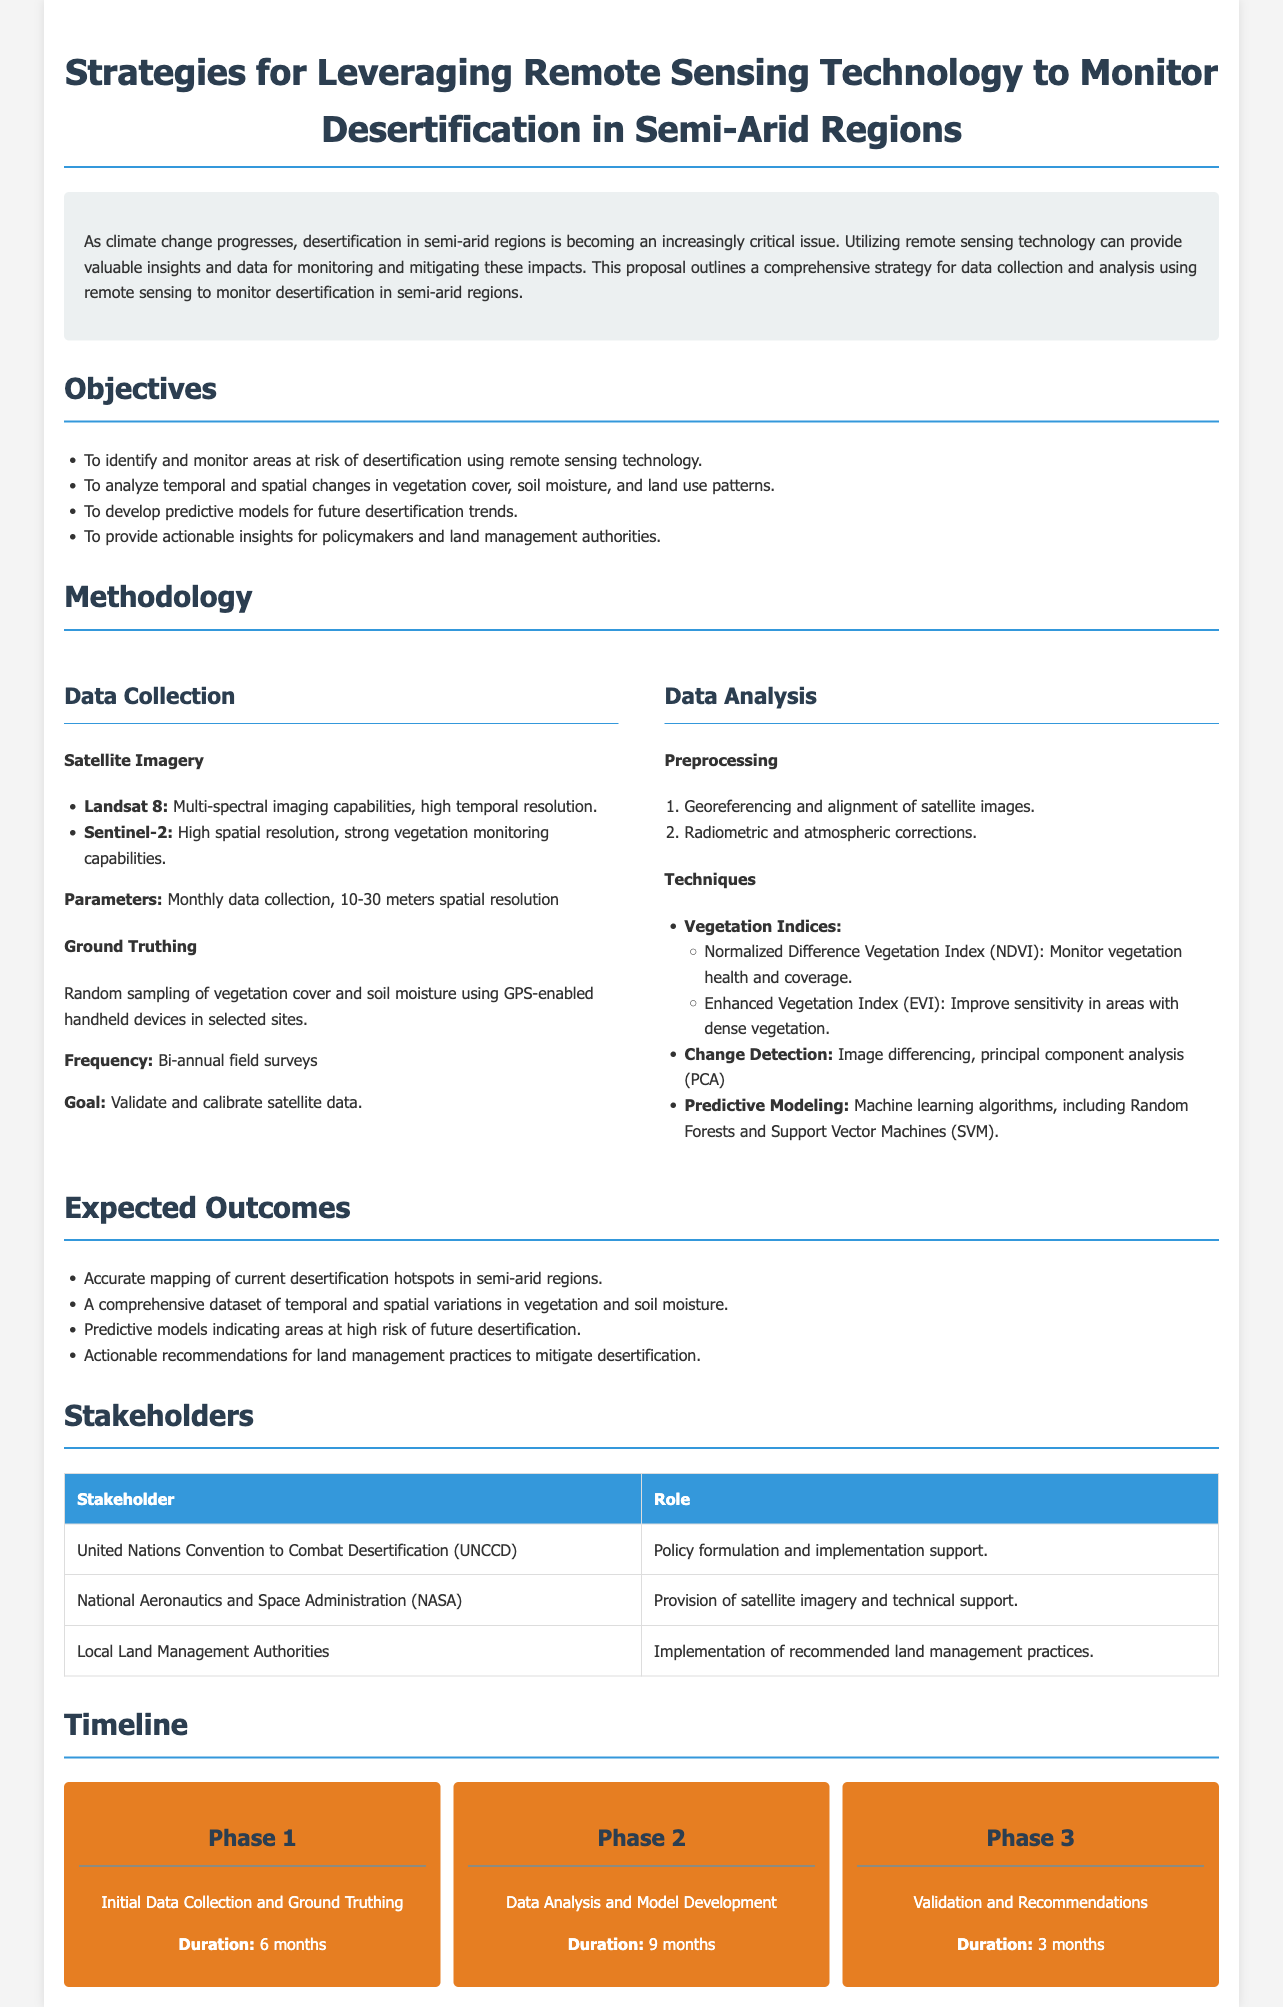What are the main objectives of the proposal? The proposal lists four objectives centered around monitoring desertification in semi-arid regions using remote sensing technology.
Answer: Identify and monitor areas at risk of desertification, analyze temporal and spatial changes, develop predictive models, provide actionable insights Which satellite imagery is mentioned for data collection? The proposal mentions two specific satellite imagery sources suitable for monitoring desertification.
Answer: Landsat 8, Sentinel-2 What is the frequency of ground truthing field surveys? The proposal specifies how often field surveys will be conducted to validate satellite data.
Answer: Bi-annual What machine learning algorithms are proposed for predictive modeling? The proposal lists specific machine learning algorithms to be used in building predictive models regarding desertification trends.
Answer: Random Forests and Support Vector Machines What is the duration of Phase 1 in the timeline? The timeline in the proposal outlines the duration allocated for the initial phase of the project.
Answer: 6 months Who is responsible for policy formulation in this proposal? The proposal identifies a key stakeholder involved in policy development related to desertification management.
Answer: United Nations Convention to Combat Desertification What vegetation index is used to monitor vegetation health? The proposal discusses types of vegetation indices used to assess the state of health and coverage of vegetation.
Answer: Normalized Difference Vegetation Index (NDVI) What is the goal of ground truthing? The proposal states the objective of conducting ground truthing in relation to satellite data.
Answer: Validate and calibrate satellite data What will the expected outcomes include? The proposal presents several anticipated results from the project's implementation regarding desertification mapping and analysis.
Answer: Accurate mapping of current desertification hotspots, a comprehensive dataset, predictive models, actionable recommendations 